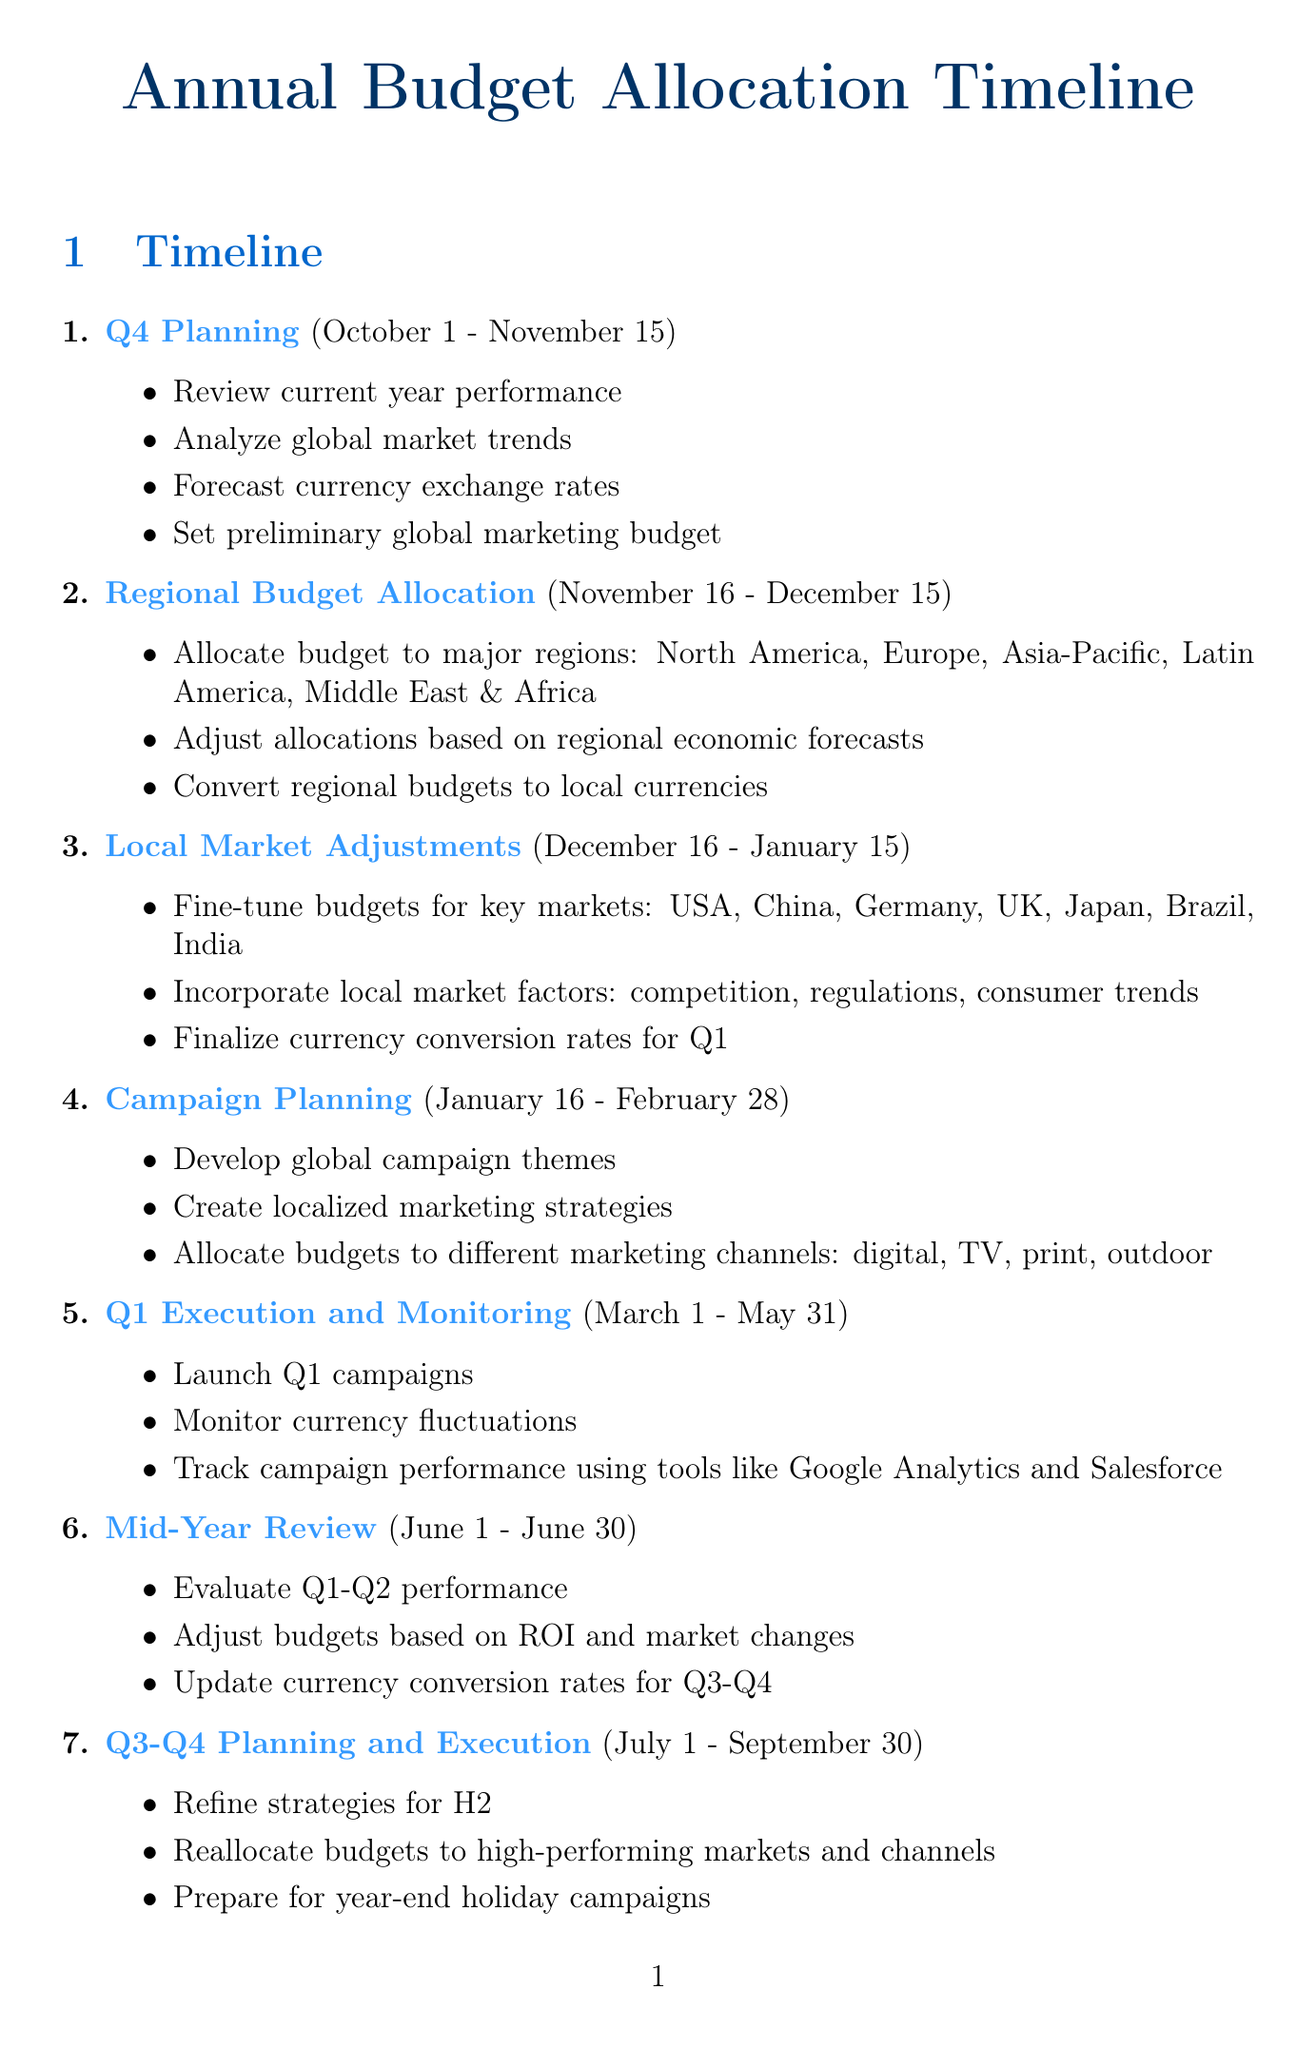What is the timeframe for Q4 Planning? The timeframe for Q4 Planning is listed as October 1 - November 15.
Answer: October 1 - November 15 Which tool is used for expense management and budget tracking? The document specifies that SAP Concur is used for expense management and budget tracking.
Answer: SAP Concur What performance metrics are evaluated in the Mid-Year Review? The Mid-Year Review evaluates Q1-Q2 performance, adjustments based on ROI, and updates to currency conversion rates for Q3-Q4.
Answer: Q1-Q2 performance During which phase is the preliminary global marketing budget set? The document specifies that the preliminary global marketing budget is set during the Q4 Planning phase.
Answer: Q4 Planning What local market factors are considered for Germany? The document lists GDPR compliance costs, automotive industry performance, and green marketing trends as factors for Germany.
Answer: GDPR compliance costs; automotive industry performance; green marketing trends Which currency pair considers Brexit developments? The document indicates that the USD/GBP currency pair considers Brexit developments.
Answer: USD/GBP How long is the Q1 Execution and Monitoring phase? The timeframe for Q1 Execution and Monitoring is provided as March 1 - May 31.
Answer: March 1 - May 31 What market adjustment factor is specific to Brazil? The document identifies inflation rate, soccer event schedules, and regional economic disparities as market adjustment factors for Brazil.
Answer: Inflation rate; soccer event schedules; regional economic disparities 